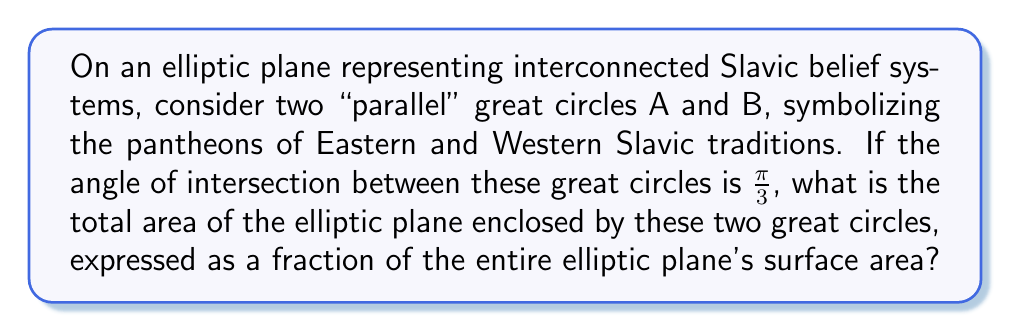Provide a solution to this math problem. Let's approach this step-by-step:

1) In elliptic geometry, "parallel" lines are great circles that intersect at two antipodal points.

2) The angle of intersection between the great circles is given as $\frac{\pi}{3}$ or 60°.

3) In elliptic geometry, the sum of the angles in a triangle is greater than $\pi$ (180°). For a triangle formed by two great circles and the equator, the sum of angles is $\pi + \alpha$, where $\alpha$ is the angle between the great circles.

4) In our case, $\alpha = \frac{\pi}{3}$, so the sum of angles in the triangle is $\pi + \frac{\pi}{3} = \frac{4\pi}{3}$.

5) The area of a triangle in elliptic geometry is given by its excess angle: $Area = r^2(sum of angles - \pi)$, where $r$ is the radius of the sphere.

6) Therefore, the area of our triangle is: $r^2(\frac{4\pi}{3} - \pi) = r^2(\frac{\pi}{3})$

7) The two great circles divide the elliptic plane into four congruent triangles. We're interested in the area of two of these triangles.

8) The area we're looking for is thus: $2 * r^2(\frac{\pi}{3}) = \frac{2\pi r^2}{3}$

9) The total surface area of the elliptic plane (sphere) is $4\pi r^2$.

10) The fraction of the elliptic plane's surface area enclosed by the two great circles is:

   $$\frac{\frac{2\pi r^2}{3}}{4\pi r^2} = \frac{1}{6}$$

This fraction represents the interconnectedness of Eastern and Western Slavic pantheons in our metaphorical representation.
Answer: $\frac{1}{6}$ 